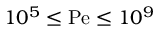Convert formula to latex. <formula><loc_0><loc_0><loc_500><loc_500>1 0 ^ { 5 } \leq P e \leq 1 0 ^ { 9 }</formula> 